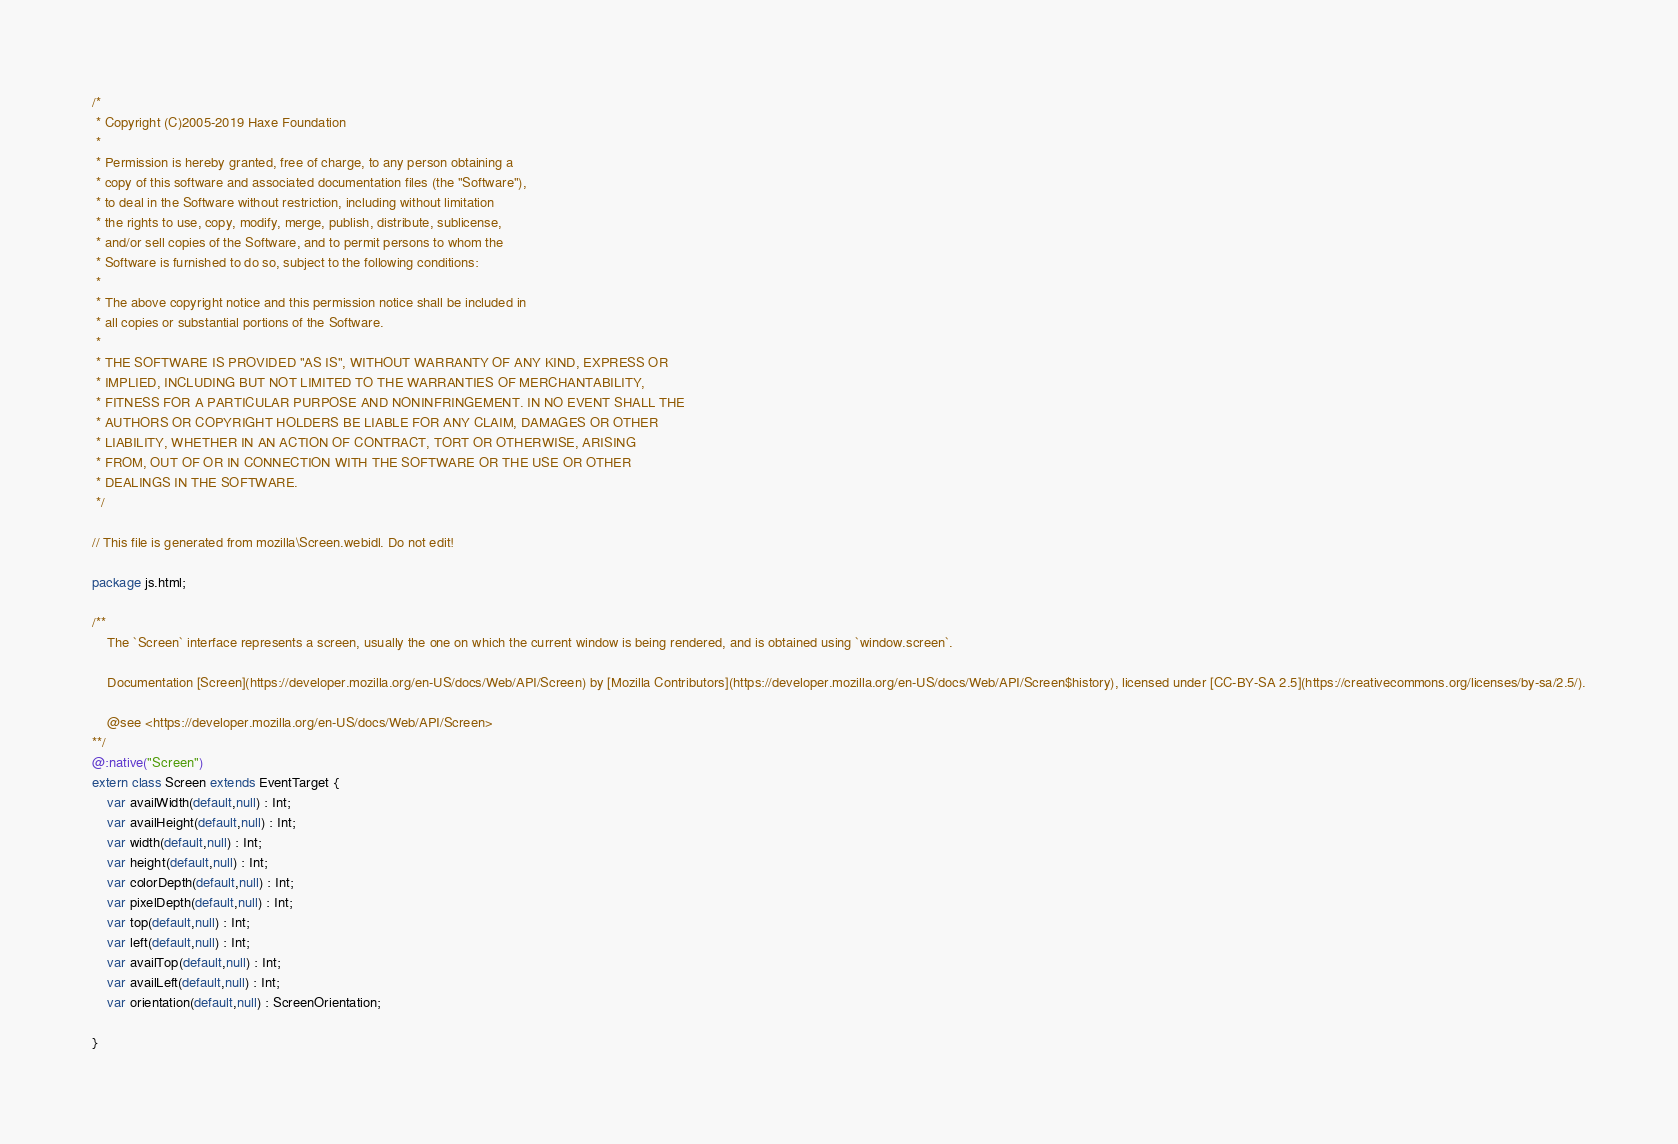Convert code to text. <code><loc_0><loc_0><loc_500><loc_500><_Haxe_>/*
 * Copyright (C)2005-2019 Haxe Foundation
 *
 * Permission is hereby granted, free of charge, to any person obtaining a
 * copy of this software and associated documentation files (the "Software"),
 * to deal in the Software without restriction, including without limitation
 * the rights to use, copy, modify, merge, publish, distribute, sublicense,
 * and/or sell copies of the Software, and to permit persons to whom the
 * Software is furnished to do so, subject to the following conditions:
 *
 * The above copyright notice and this permission notice shall be included in
 * all copies or substantial portions of the Software.
 *
 * THE SOFTWARE IS PROVIDED "AS IS", WITHOUT WARRANTY OF ANY KIND, EXPRESS OR
 * IMPLIED, INCLUDING BUT NOT LIMITED TO THE WARRANTIES OF MERCHANTABILITY,
 * FITNESS FOR A PARTICULAR PURPOSE AND NONINFRINGEMENT. IN NO EVENT SHALL THE
 * AUTHORS OR COPYRIGHT HOLDERS BE LIABLE FOR ANY CLAIM, DAMAGES OR OTHER
 * LIABILITY, WHETHER IN AN ACTION OF CONTRACT, TORT OR OTHERWISE, ARISING
 * FROM, OUT OF OR IN CONNECTION WITH THE SOFTWARE OR THE USE OR OTHER
 * DEALINGS IN THE SOFTWARE.
 */

// This file is generated from mozilla\Screen.webidl. Do not edit!

package js.html;

/**
	The `Screen` interface represents a screen, usually the one on which the current window is being rendered, and is obtained using `window.screen`.

	Documentation [Screen](https://developer.mozilla.org/en-US/docs/Web/API/Screen) by [Mozilla Contributors](https://developer.mozilla.org/en-US/docs/Web/API/Screen$history), licensed under [CC-BY-SA 2.5](https://creativecommons.org/licenses/by-sa/2.5/).

	@see <https://developer.mozilla.org/en-US/docs/Web/API/Screen>
**/
@:native("Screen")
extern class Screen extends EventTarget {
	var availWidth(default,null) : Int;
	var availHeight(default,null) : Int;
	var width(default,null) : Int;
	var height(default,null) : Int;
	var colorDepth(default,null) : Int;
	var pixelDepth(default,null) : Int;
	var top(default,null) : Int;
	var left(default,null) : Int;
	var availTop(default,null) : Int;
	var availLeft(default,null) : Int;
	var orientation(default,null) : ScreenOrientation;
	
}</code> 